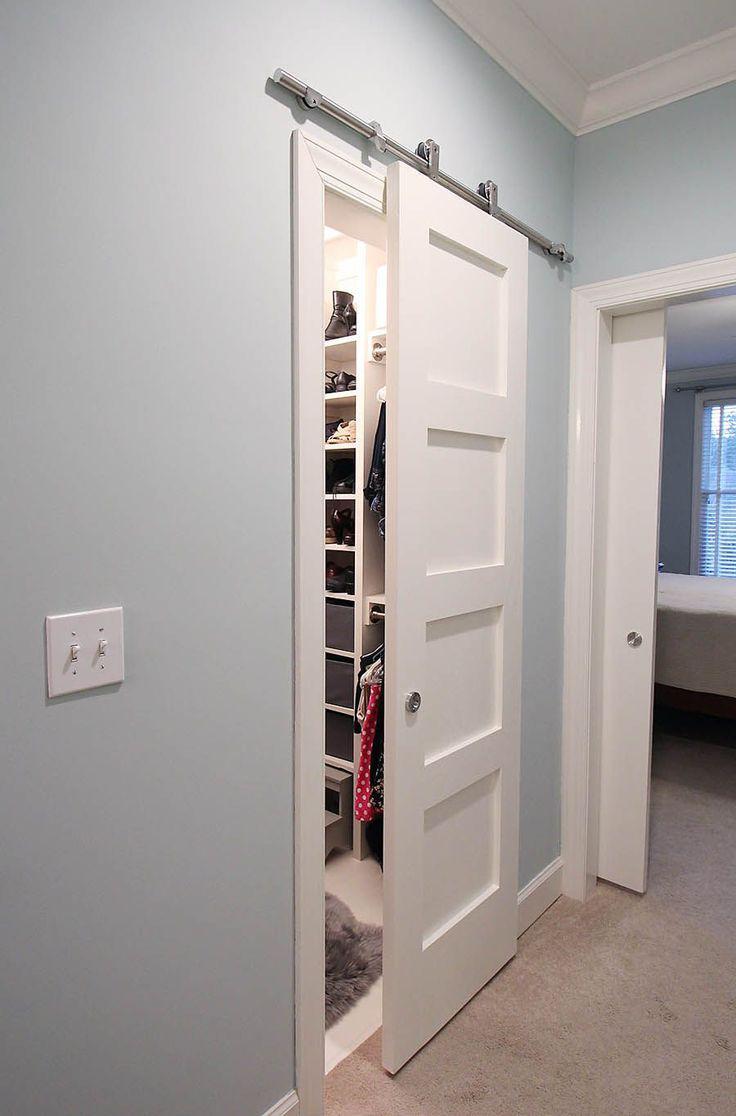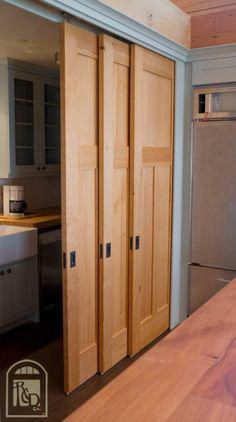The first image is the image on the left, the second image is the image on the right. For the images displayed, is the sentence "There is a closet white sliding doors in one of the images." factually correct? Answer yes or no. Yes. The first image is the image on the left, the second image is the image on the right. Assess this claim about the two images: "A white sliding closet door on overhead bar is standing open.". Correct or not? Answer yes or no. Yes. 